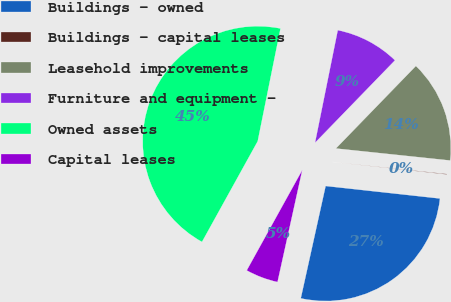Convert chart to OTSL. <chart><loc_0><loc_0><loc_500><loc_500><pie_chart><fcel>Buildings - owned<fcel>Buildings - capital leases<fcel>Leasehold improvements<fcel>Furniture and equipment -<fcel>Owned assets<fcel>Capital leases<nl><fcel>26.73%<fcel>0.07%<fcel>14.41%<fcel>9.08%<fcel>45.13%<fcel>4.58%<nl></chart> 